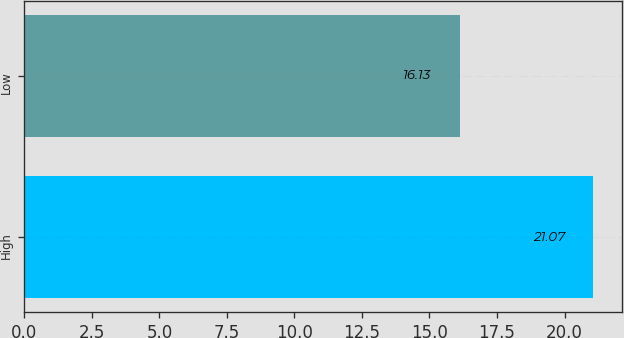<chart> <loc_0><loc_0><loc_500><loc_500><bar_chart><fcel>High<fcel>Low<nl><fcel>21.07<fcel>16.13<nl></chart> 